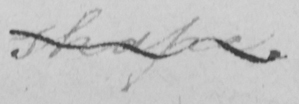What is written in this line of handwriting? shape . 